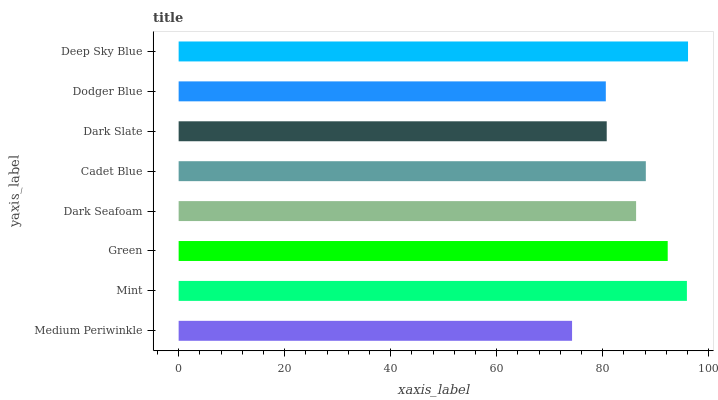Is Medium Periwinkle the minimum?
Answer yes or no. Yes. Is Deep Sky Blue the maximum?
Answer yes or no. Yes. Is Mint the minimum?
Answer yes or no. No. Is Mint the maximum?
Answer yes or no. No. Is Mint greater than Medium Periwinkle?
Answer yes or no. Yes. Is Medium Periwinkle less than Mint?
Answer yes or no. Yes. Is Medium Periwinkle greater than Mint?
Answer yes or no. No. Is Mint less than Medium Periwinkle?
Answer yes or no. No. Is Cadet Blue the high median?
Answer yes or no. Yes. Is Dark Seafoam the low median?
Answer yes or no. Yes. Is Dark Seafoam the high median?
Answer yes or no. No. Is Green the low median?
Answer yes or no. No. 